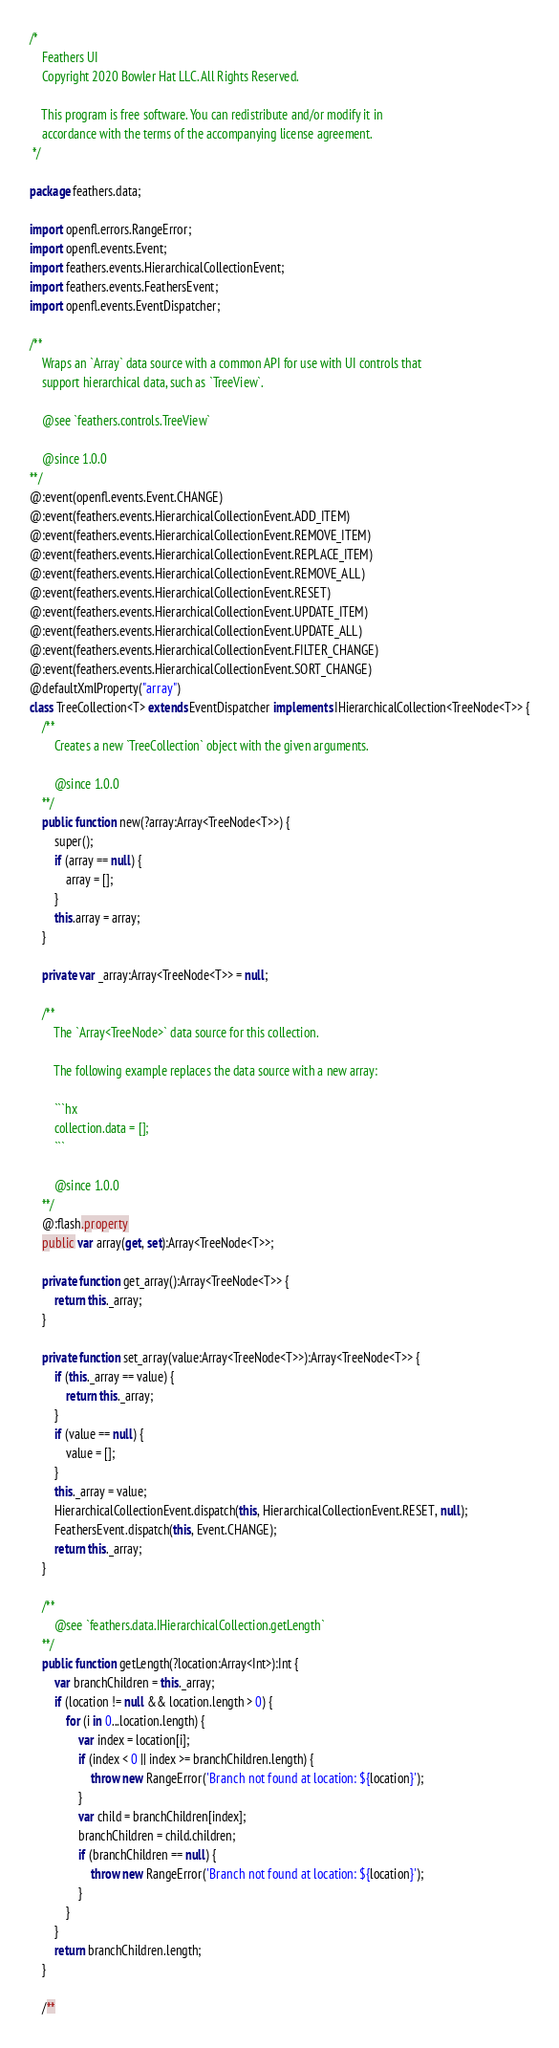<code> <loc_0><loc_0><loc_500><loc_500><_Haxe_>/*
	Feathers UI
	Copyright 2020 Bowler Hat LLC. All Rights Reserved.

	This program is free software. You can redistribute and/or modify it in
	accordance with the terms of the accompanying license agreement.
 */

package feathers.data;

import openfl.errors.RangeError;
import openfl.events.Event;
import feathers.events.HierarchicalCollectionEvent;
import feathers.events.FeathersEvent;
import openfl.events.EventDispatcher;

/**
	Wraps an `Array` data source with a common API for use with UI controls that
	support hierarchical data, such as `TreeView`.

	@see `feathers.controls.TreeView`

	@since 1.0.0
**/
@:event(openfl.events.Event.CHANGE)
@:event(feathers.events.HierarchicalCollectionEvent.ADD_ITEM)
@:event(feathers.events.HierarchicalCollectionEvent.REMOVE_ITEM)
@:event(feathers.events.HierarchicalCollectionEvent.REPLACE_ITEM)
@:event(feathers.events.HierarchicalCollectionEvent.REMOVE_ALL)
@:event(feathers.events.HierarchicalCollectionEvent.RESET)
@:event(feathers.events.HierarchicalCollectionEvent.UPDATE_ITEM)
@:event(feathers.events.HierarchicalCollectionEvent.UPDATE_ALL)
@:event(feathers.events.HierarchicalCollectionEvent.FILTER_CHANGE)
@:event(feathers.events.HierarchicalCollectionEvent.SORT_CHANGE)
@defaultXmlProperty("array")
class TreeCollection<T> extends EventDispatcher implements IHierarchicalCollection<TreeNode<T>> {
	/**
		Creates a new `TreeCollection` object with the given arguments.

		@since 1.0.0
	**/
	public function new(?array:Array<TreeNode<T>>) {
		super();
		if (array == null) {
			array = [];
		}
		this.array = array;
	}

	private var _array:Array<TreeNode<T>> = null;

	/**
		The `Array<TreeNode>` data source for this collection.

		The following example replaces the data source with a new array:

		```hx
		collection.data = [];
		```

		@since 1.0.0
	**/
	@:flash.property
	public var array(get, set):Array<TreeNode<T>>;

	private function get_array():Array<TreeNode<T>> {
		return this._array;
	}

	private function set_array(value:Array<TreeNode<T>>):Array<TreeNode<T>> {
		if (this._array == value) {
			return this._array;
		}
		if (value == null) {
			value = [];
		}
		this._array = value;
		HierarchicalCollectionEvent.dispatch(this, HierarchicalCollectionEvent.RESET, null);
		FeathersEvent.dispatch(this, Event.CHANGE);
		return this._array;
	}

	/**
		@see `feathers.data.IHierarchicalCollection.getLength`
	**/
	public function getLength(?location:Array<Int>):Int {
		var branchChildren = this._array;
		if (location != null && location.length > 0) {
			for (i in 0...location.length) {
				var index = location[i];
				if (index < 0 || index >= branchChildren.length) {
					throw new RangeError('Branch not found at location: ${location}');
				}
				var child = branchChildren[index];
				branchChildren = child.children;
				if (branchChildren == null) {
					throw new RangeError('Branch not found at location: ${location}');
				}
			}
		}
		return branchChildren.length;
	}

	/**</code> 